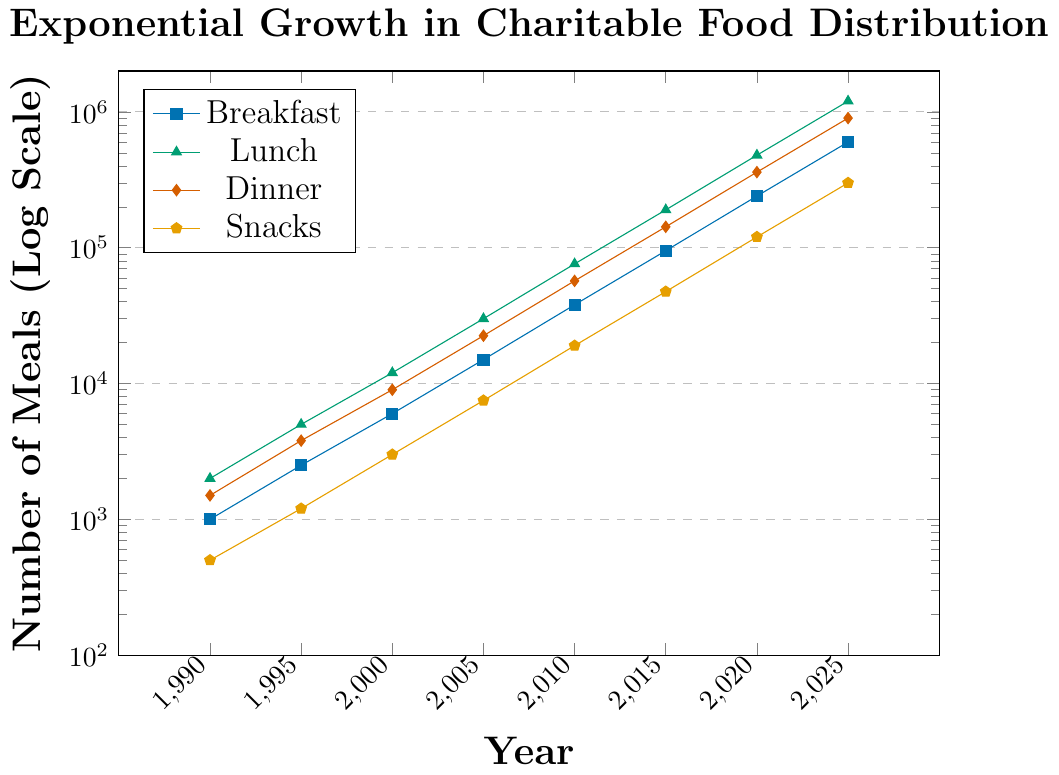What year did lunch meals first exceed 100,000? To determine when lunch meals first exceed 100,000, we refer to the lunch data on the chart. The value surpasses 100,000 between 2010 (76,000) and 2015 (190,000). So, it first exceeds 100,000 in 2015.
Answer: 2015 Which type of meal had the highest growth rate from 1990 to 2025? To find the highest growth rate, we compare the ratios of the numbers from 1990 to 2025 for each meal type. Breakfast grows from 1000 to 600,000 (600x), Lunch from 2000 to 1,200,000 (600x), Dinner from 1500 to 900,000 (600x), and Snacks from 500 to 300,000 (600x). All meal types grew at the same highest rate.
Answer: All meals How many more lunch meals were distributed than breakfast meals in 2020? The number of lunch meals in 2020 is 480,000 and the number of breakfast meals is 240,000. The difference is 480,000 - 240,000 = 240,000.
Answer: 240,000 Of the years shown, in which year were the most dinner meals served? The most dinner meals served can be identified by looking at the last data point on the dinner line. The highest value is in 2025, with 900,000 meals.
Answer: 2025 What is the average number of breakfast meals served from 1990 to 2000? The breakfast meals served from 1990 to 2000 are 1,000, 2,500, and 6,000. The sum is 1,000 + 2,500 + 6,000 = 9,500. There are 3 data points: 9,500 / 3 = 3,167.
Answer: 3,167 By how much did the number of snack meals increase between 2000 and 2005? Snack meals in 2000 were 3,000 and in 2005 were 7,500. The increase is 7,500 - 3,000 = 4,500.
Answer: 4,500 In which year did the distribution of dinner meals approximate the sum of breakfast and snack meals? We need to find when dinner meals are close to the sum of breakfast and snack meals. In 2000, Dinner: 9,000, Breakfast+Snacks: 6,000 + 3,000 = 9,000.
Answer: 2000 Which type of meal has consistently shown the least growth between 1990 and 2025? Reviewing the consistent growth for each meal, snack meals exhibit the least growth because its final value and intermediate growth are always on the lower side.
Answer: Snacks How many total meals were distributed in 2010 across all types? In 2010, Breakfast: 38,000, Lunch: 76,000, Dinner: 57,000, Snacks: 19,000. Total: 38,000 + 76,000 + 57,000 + 19,000 = 190,000.
Answer: 190,000 Which meal type had the highest distribution in 1990? To find the meal type with the highest distribution in 1990, we compare the values: Breakfast: 1,000, Lunch: 2,000, Dinner: 1,500, Snacks: 500. Lunch is the highest.
Answer: Lunch 